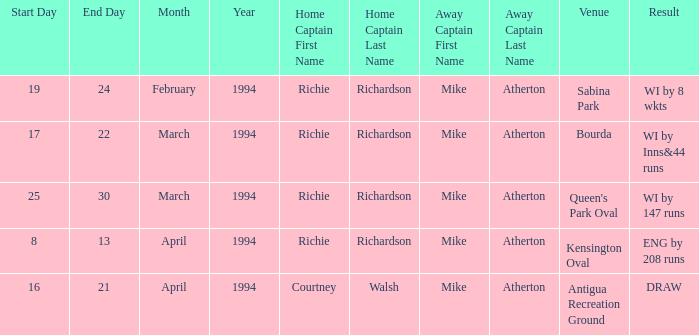Can you give me this table as a dict? {'header': ['Start Day', 'End Day', 'Month', 'Year', 'Home Captain First Name', 'Home Captain Last Name', 'Away Captain First Name', 'Away Captain Last Name', 'Venue', 'Result'], 'rows': [['19', '24', 'February', '1994', 'Richie', 'Richardson', 'Mike', 'Atherton', 'Sabina Park', 'WI by 8 wkts'], ['17', '22', 'March', '1994', 'Richie', 'Richardson', 'Mike', 'Atherton', 'Bourda', 'WI by Inns&44 runs'], ['25', '30', 'March', '1994', 'Richie', 'Richardson', 'Mike', 'Atherton', "Queen's Park Oval", 'WI by 147 runs'], ['8', '13', 'April', '1994', 'Richie', 'Richardson', 'Mike', 'Atherton', 'Kensington Oval', 'ENG by 208 runs'], ['16', '21', 'April', '1994', 'Courtney', 'Walsh', 'Mike', 'Atherton', 'Antigua Recreation Ground', 'DRAW']]} Which home captain is associated with the bourda venue? Richie Richardson. 